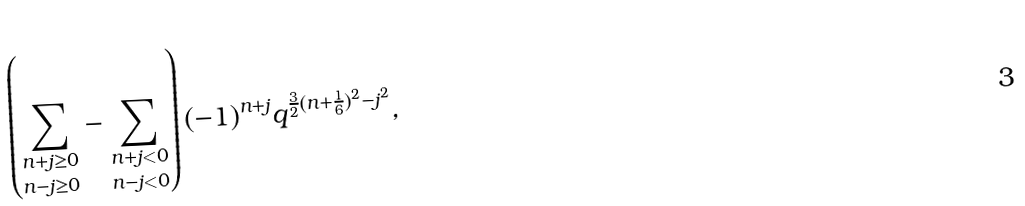Convert formula to latex. <formula><loc_0><loc_0><loc_500><loc_500>\left ( \underset { n - j \geq 0 } { \sum _ { n + j \geq 0 } } - \underset { n - j < 0 } { \sum _ { n + j < 0 } } \right ) ( - 1 ) ^ { n + j } q ^ { \frac { 3 } { 2 } ( n + \frac { 1 } { 6 } ) ^ { 2 } - j ^ { 2 } } ,</formula> 